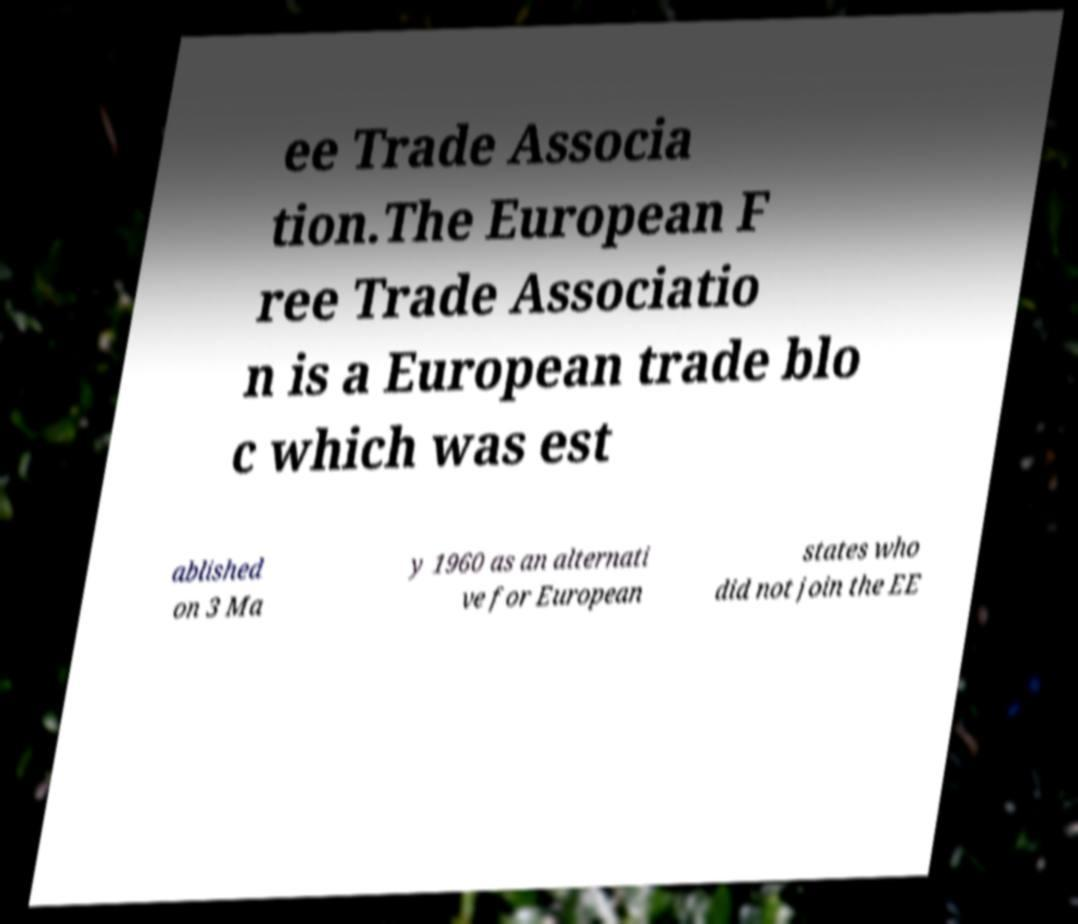Could you extract and type out the text from this image? ee Trade Associa tion.The European F ree Trade Associatio n is a European trade blo c which was est ablished on 3 Ma y 1960 as an alternati ve for European states who did not join the EE 